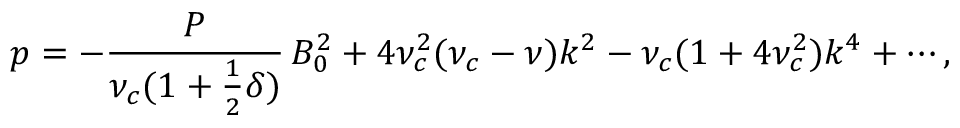Convert formula to latex. <formula><loc_0><loc_0><loc_500><loc_500>p = - \frac { P } { \nu _ { c } ( 1 + \frac { 1 } { 2 } \delta ) } \, B _ { 0 } ^ { 2 } + 4 \nu _ { c } ^ { 2 } ( \nu _ { c } - \nu ) k ^ { 2 } - \nu _ { c } ( 1 + 4 \nu _ { c } ^ { 2 } ) k ^ { 4 } + \cdots ,</formula> 